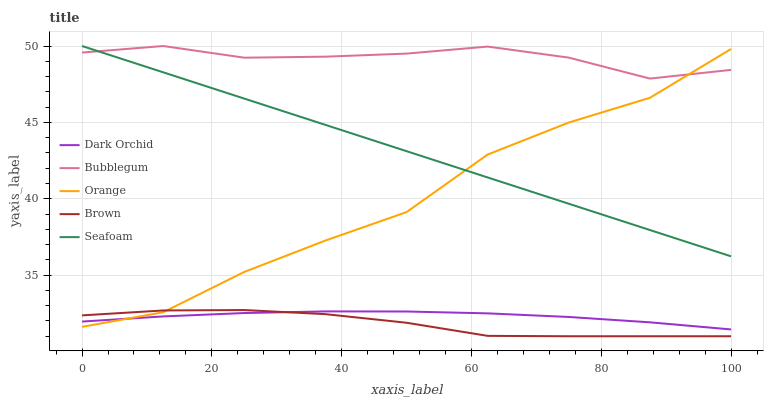Does Brown have the minimum area under the curve?
Answer yes or no. Yes. Does Bubblegum have the maximum area under the curve?
Answer yes or no. Yes. Does Bubblegum have the minimum area under the curve?
Answer yes or no. No. Does Brown have the maximum area under the curve?
Answer yes or no. No. Is Seafoam the smoothest?
Answer yes or no. Yes. Is Orange the roughest?
Answer yes or no. Yes. Is Brown the smoothest?
Answer yes or no. No. Is Brown the roughest?
Answer yes or no. No. Does Brown have the lowest value?
Answer yes or no. Yes. Does Bubblegum have the lowest value?
Answer yes or no. No. Does Seafoam have the highest value?
Answer yes or no. Yes. Does Brown have the highest value?
Answer yes or no. No. Is Brown less than Seafoam?
Answer yes or no. Yes. Is Seafoam greater than Brown?
Answer yes or no. Yes. Does Orange intersect Seafoam?
Answer yes or no. Yes. Is Orange less than Seafoam?
Answer yes or no. No. Is Orange greater than Seafoam?
Answer yes or no. No. Does Brown intersect Seafoam?
Answer yes or no. No. 